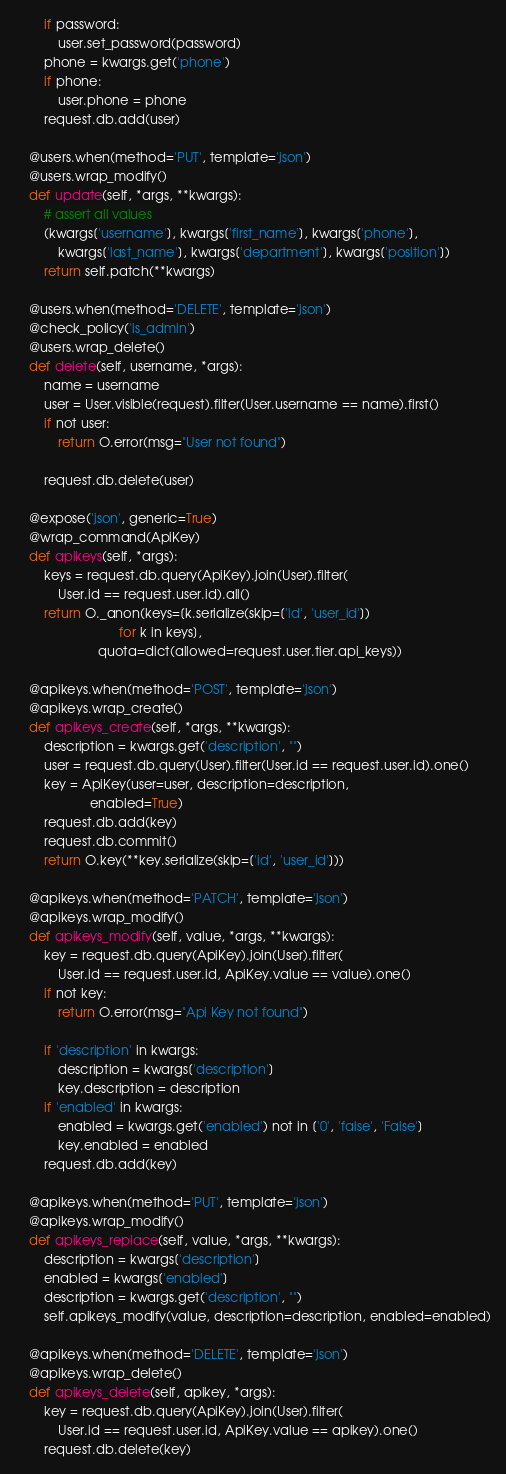Convert code to text. <code><loc_0><loc_0><loc_500><loc_500><_Python_>        if password:
            user.set_password(password)
        phone = kwargs.get('phone')
        if phone:
            user.phone = phone
        request.db.add(user)

    @users.when(method='PUT', template='json')
    @users.wrap_modify()
    def update(self, *args, **kwargs):
        # assert all values
        (kwargs['username'], kwargs['first_name'], kwargs['phone'],
            kwargs['last_name'], kwargs['department'], kwargs['position'])
        return self.patch(**kwargs)

    @users.when(method='DELETE', template='json')
    @check_policy('is_admin')
    @users.wrap_delete()
    def delete(self, username, *args):
        name = username
        user = User.visible(request).filter(User.username == name).first()
        if not user:
            return O.error(msg="User not found")

        request.db.delete(user)

    @expose('json', generic=True)
    @wrap_command(ApiKey)
    def apikeys(self, *args):
        keys = request.db.query(ApiKey).join(User).filter(
            User.id == request.user.id).all()
        return O._anon(keys=[k.serialize(skip=['id', 'user_id'])
                             for k in keys],
                       quota=dict(allowed=request.user.tier.api_keys))

    @apikeys.when(method='POST', template='json')
    @apikeys.wrap_create()
    def apikeys_create(self, *args, **kwargs):
        description = kwargs.get('description', "")
        user = request.db.query(User).filter(User.id == request.user.id).one()
        key = ApiKey(user=user, description=description,
                     enabled=True)
        request.db.add(key)
        request.db.commit()
        return O.key(**key.serialize(skip=['id', 'user_id']))

    @apikeys.when(method='PATCH', template='json')
    @apikeys.wrap_modify()
    def apikeys_modify(self, value, *args, **kwargs):
        key = request.db.query(ApiKey).join(User).filter(
            User.id == request.user.id, ApiKey.value == value).one()
        if not key:
            return O.error(msg="Api Key not found")

        if 'description' in kwargs:
            description = kwargs['description']
            key.description = description
        if 'enabled' in kwargs:
            enabled = kwargs.get('enabled') not in ['0', 'false', 'False']
            key.enabled = enabled
        request.db.add(key)

    @apikeys.when(method='PUT', template='json')
    @apikeys.wrap_modify()
    def apikeys_replace(self, value, *args, **kwargs):
        description = kwargs['description']
        enabled = kwargs['enabled']
        description = kwargs.get('description', "")
        self.apikeys_modify(value, description=description, enabled=enabled)

    @apikeys.when(method='DELETE', template='json')
    @apikeys.wrap_delete()
    def apikeys_delete(self, apikey, *args):
        key = request.db.query(ApiKey).join(User).filter(
            User.id == request.user.id, ApiKey.value == apikey).one()
        request.db.delete(key)
</code> 